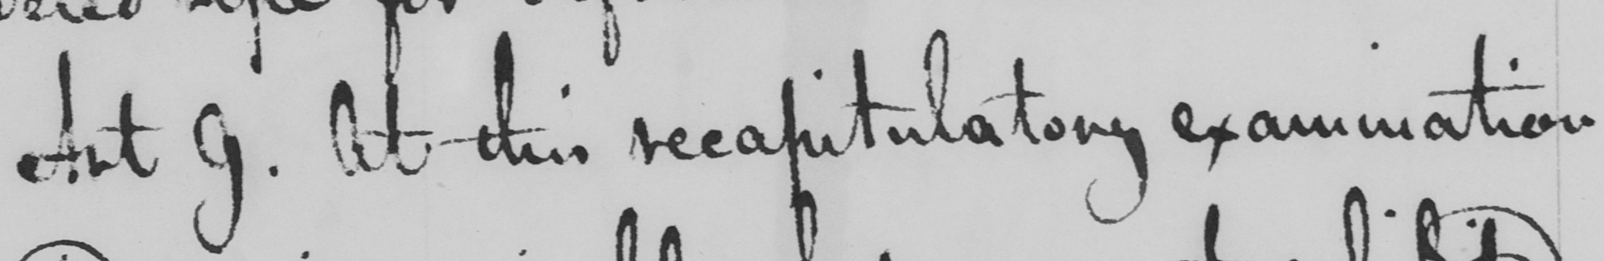Please transcribe the handwritten text in this image. Art. 9. At this recapitulatory examination 